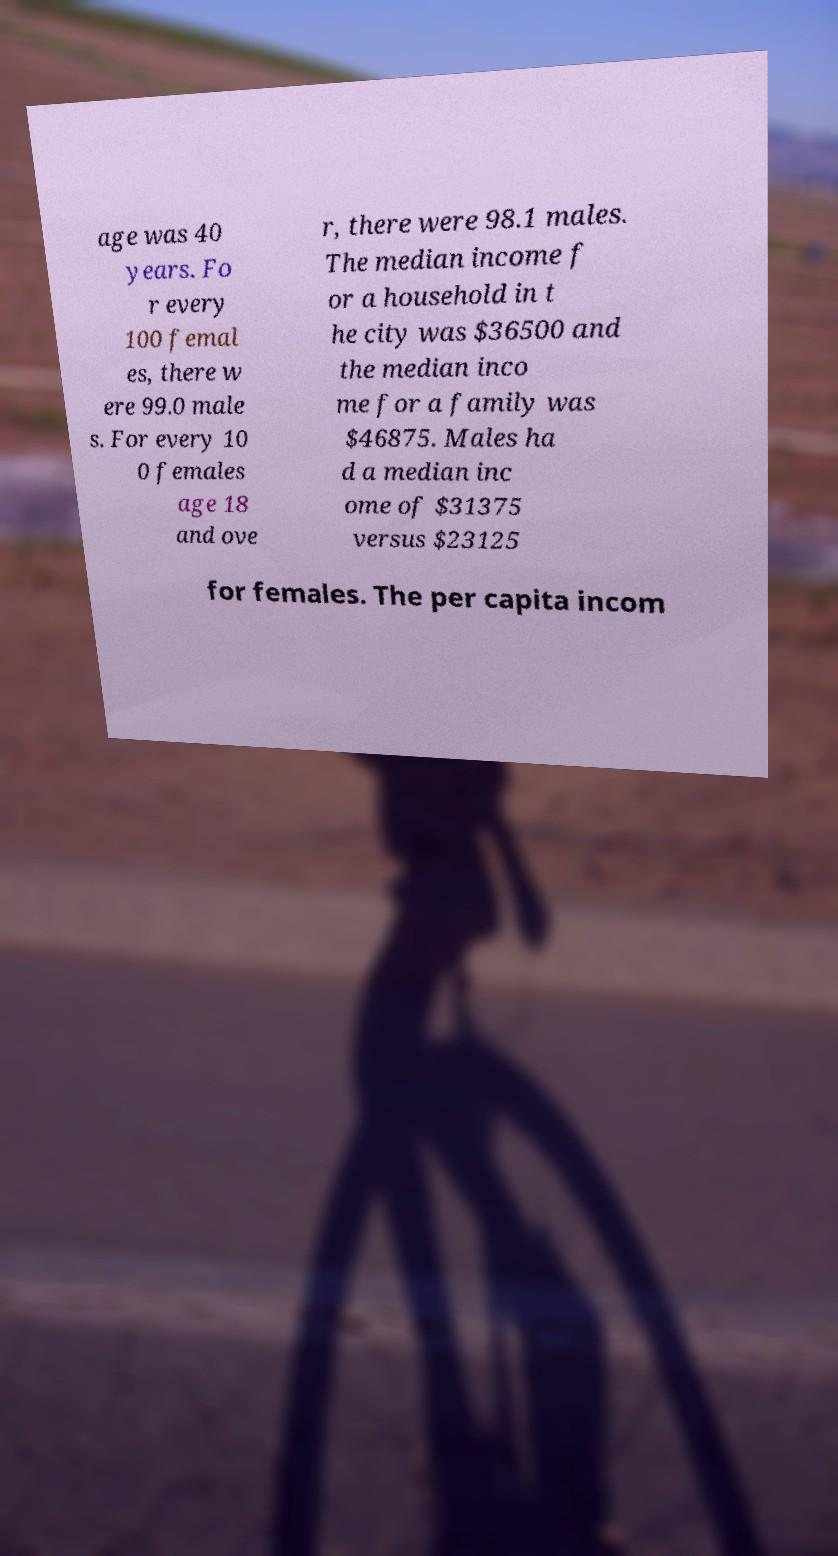Please read and relay the text visible in this image. What does it say? age was 40 years. Fo r every 100 femal es, there w ere 99.0 male s. For every 10 0 females age 18 and ove r, there were 98.1 males. The median income f or a household in t he city was $36500 and the median inco me for a family was $46875. Males ha d a median inc ome of $31375 versus $23125 for females. The per capita incom 